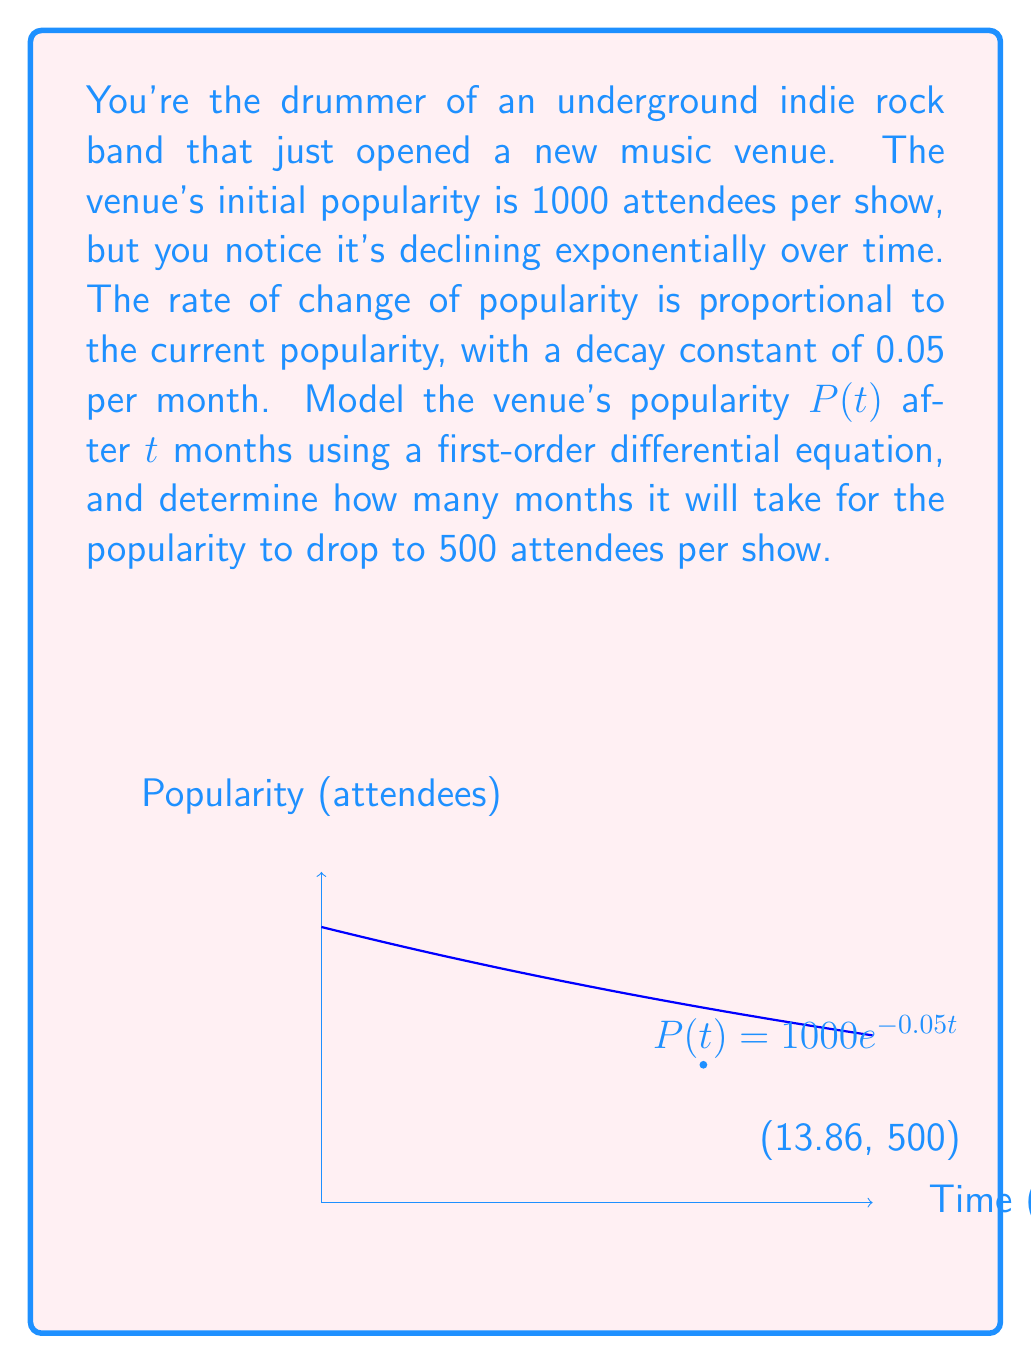Provide a solution to this math problem. 1) Let $P(t)$ be the popularity (attendees) at time $t$ (months). The rate of change is proportional to the current popularity:

   $$\frac{dP}{dt} = -kP$$

   where $k = 0.05$ is the decay constant.

2) This is a separable first-order differential equation. Rearranging:

   $$\frac{dP}{P} = -k dt$$

3) Integrating both sides:

   $$\int \frac{dP}{P} = -k \int dt$$
   $$\ln|P| = -kt + C$$

4) Solving for $P$:

   $$P(t) = Ce^{-kt}$$

5) Using the initial condition $P(0) = 1000$:

   $$1000 = Ce^{0}$$
   $$C = 1000$$

6) Therefore, the model is:

   $$P(t) = 1000e^{-0.05t}$$

7) To find when $P(t) = 500$:

   $$500 = 1000e^{-0.05t}$$
   $$\frac{1}{2} = e^{-0.05t}$$
   $$\ln(\frac{1}{2}) = -0.05t$$
   $$t = \frac{\ln(2)}{0.05} \approx 13.86$$
Answer: $P(t) = 1000e^{-0.05t}$; 13.86 months 